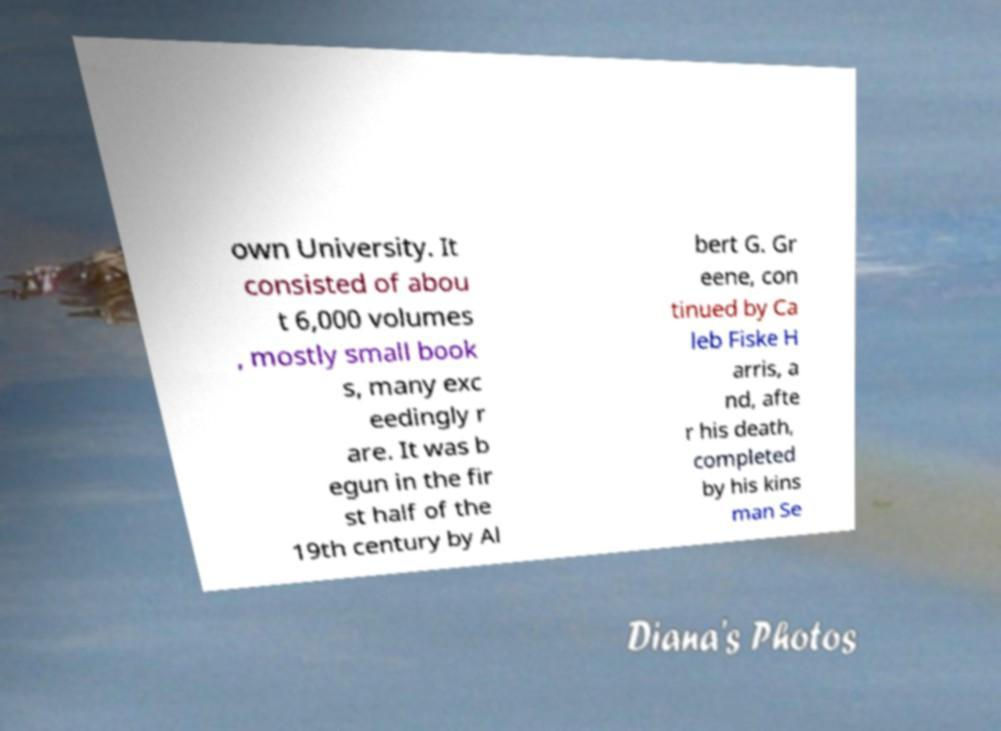Please identify and transcribe the text found in this image. own University. It consisted of abou t 6,000 volumes , mostly small book s, many exc eedingly r are. It was b egun in the fir st half of the 19th century by Al bert G. Gr eene, con tinued by Ca leb Fiske H arris, a nd, afte r his death, completed by his kins man Se 